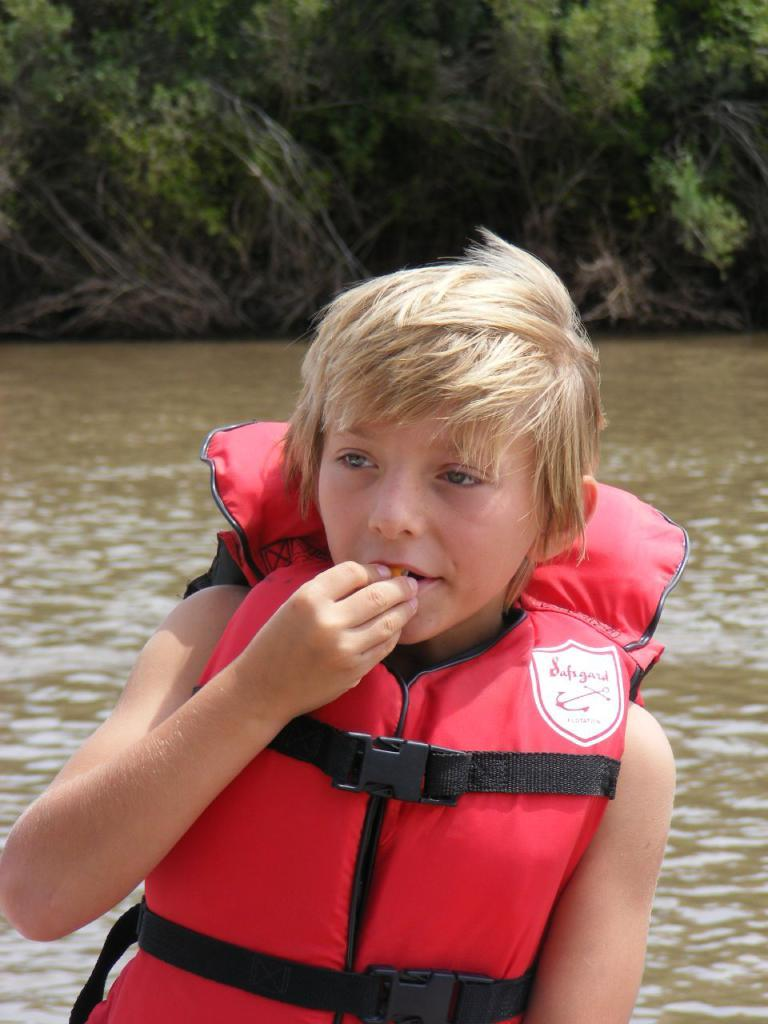What is the main subject of the image? There is a child in the image. What is the child wearing? The child is wearing a jacket. What can be seen in the background of the image? There is a water body visible in the image. Are there any plants in the image? Yes, there is a group of plants in the image. What type of magic is the child performing in the image? There is no indication of magic or any magical activity in the image. Can you see a rake being used by the child in the image? There is no rake present in the image. 